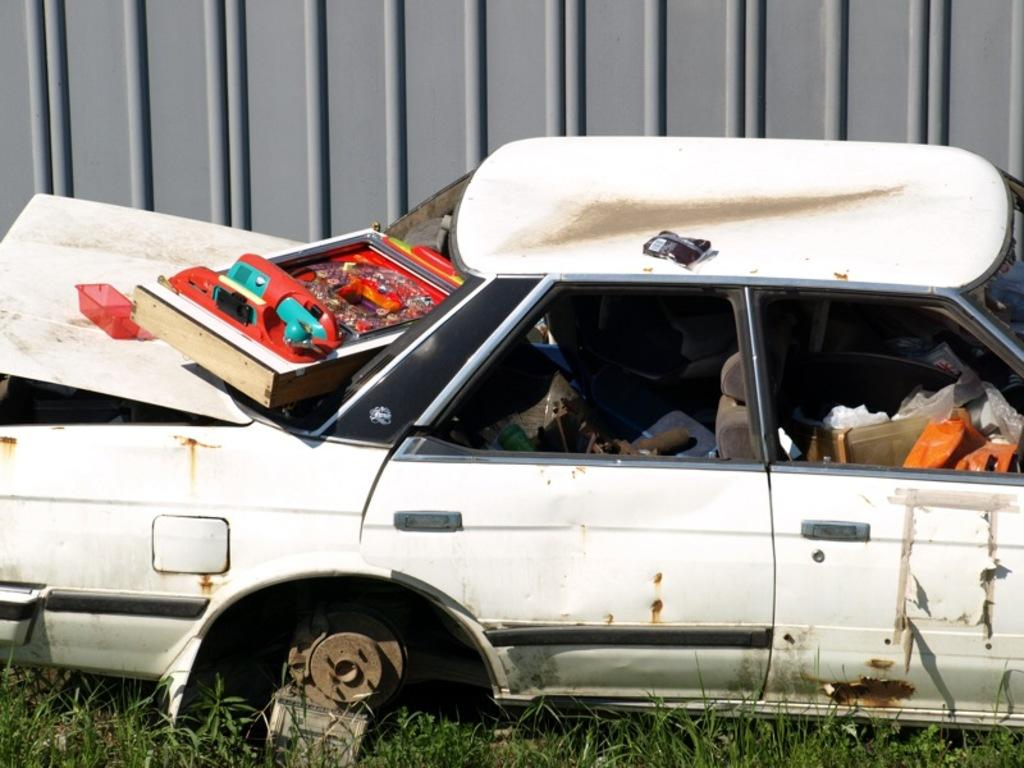What is the main subject of the image? The main subject of the image is an abandoned car on the grass. Are there any items inside the car? Yes, there are objects inside the car. What is placed on top of the car? There is an object on top of the car. Can you describe the metal object in the background? There is a metal object in the background, but its specific details are not clear from the image. What type of stamp can be seen on the car's license plate in the image? There is no stamp visible on the car's license plate in the image. 